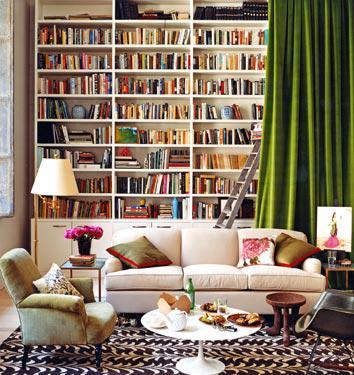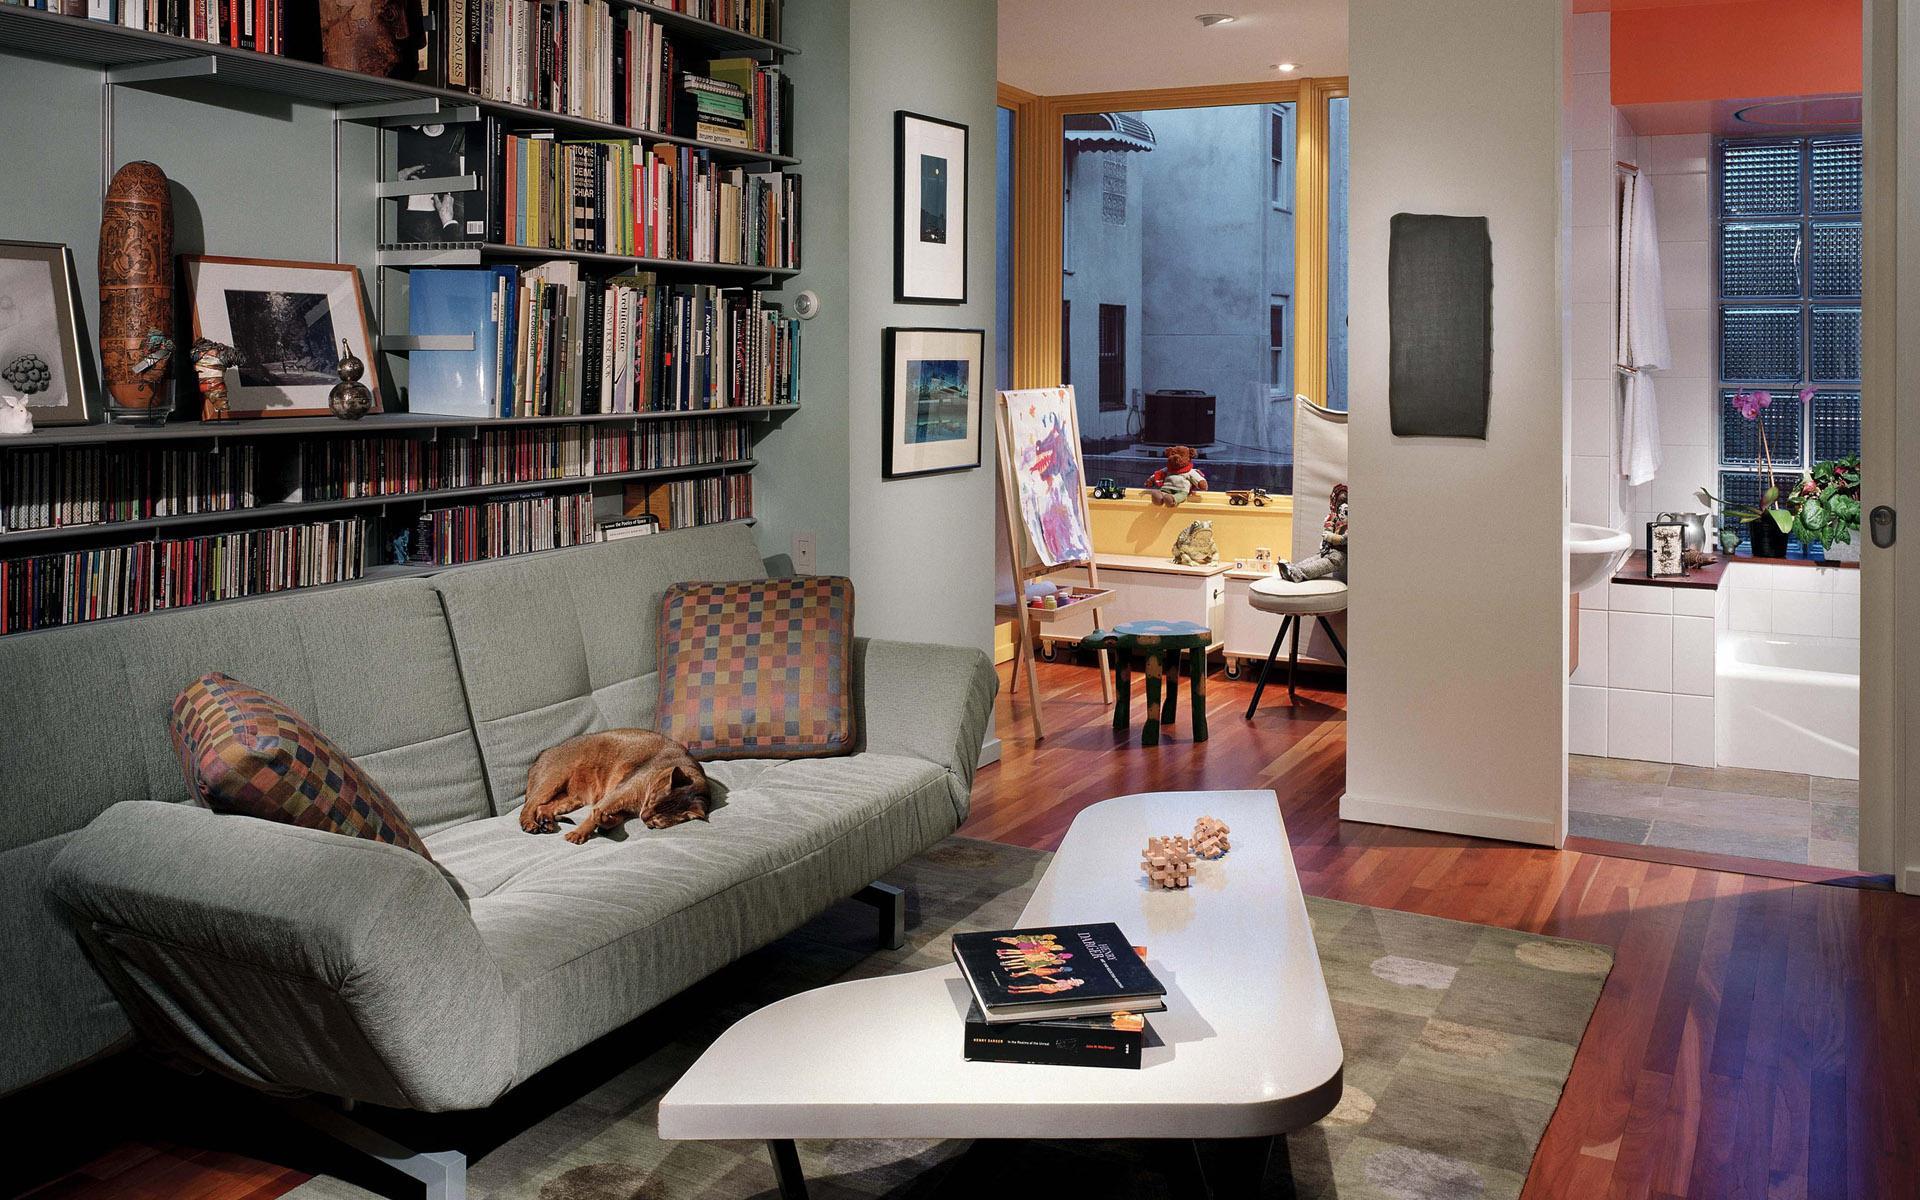The first image is the image on the left, the second image is the image on the right. Analyze the images presented: Is the assertion "A room includes a round table in front of a neutral couch, which sits in front of a wall-filling white bookcase and something olive-green." valid? Answer yes or no. Yes. 